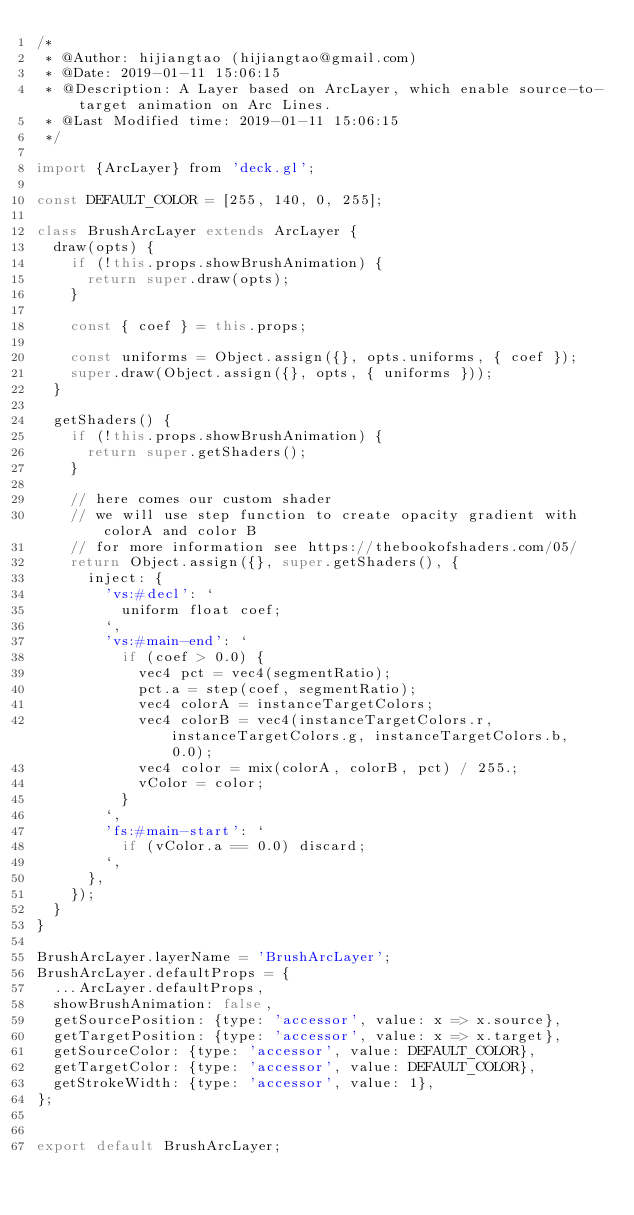Convert code to text. <code><loc_0><loc_0><loc_500><loc_500><_JavaScript_>/*
 * @Author: hijiangtao (hijiangtao@gmail.com) 
 * @Date: 2019-01-11 15:06:15 
 * @Description: A Layer based on ArcLayer, which enable source-to-target animation on Arc Lines.
 * @Last Modified time: 2019-01-11 15:06:15 
 */

import {ArcLayer} from 'deck.gl';

const DEFAULT_COLOR = [255, 140, 0, 255];

class BrushArcLayer extends ArcLayer {
  draw(opts) {
    if (!this.props.showBrushAnimation) {
      return super.draw(opts);
    }

    const { coef } = this.props;

    const uniforms = Object.assign({}, opts.uniforms, { coef });
    super.draw(Object.assign({}, opts, { uniforms }));
  }

  getShaders() {
    if (!this.props.showBrushAnimation) {
      return super.getShaders();
    }

    // here comes our custom shader
    // we will use step function to create opacity gradient with colorA and color B
    // for more information see https://thebookofshaders.com/05/
    return Object.assign({}, super.getShaders(), {
      inject: {
        'vs:#decl': `
          uniform float coef;
        `,
        'vs:#main-end': `
          if (coef > 0.0) {
            vec4 pct = vec4(segmentRatio);
            pct.a = step(coef, segmentRatio);
            vec4 colorA = instanceTargetColors;
            vec4 colorB = vec4(instanceTargetColors.r, instanceTargetColors.g, instanceTargetColors.b, 0.0);
            vec4 color = mix(colorA, colorB, pct) / 255.;
            vColor = color;
          }
        `,
        'fs:#main-start': `
          if (vColor.a == 0.0) discard;
        `,
      },
    });
  }
}

BrushArcLayer.layerName = 'BrushArcLayer';
BrushArcLayer.defaultProps = {
  ...ArcLayer.defaultProps,
  showBrushAnimation: false,
  getSourcePosition: {type: 'accessor', value: x => x.source},
  getTargetPosition: {type: 'accessor', value: x => x.target},
  getSourceColor: {type: 'accessor', value: DEFAULT_COLOR},
  getTargetColor: {type: 'accessor', value: DEFAULT_COLOR},
  getStrokeWidth: {type: 'accessor', value: 1},
};

  
export default BrushArcLayer;</code> 